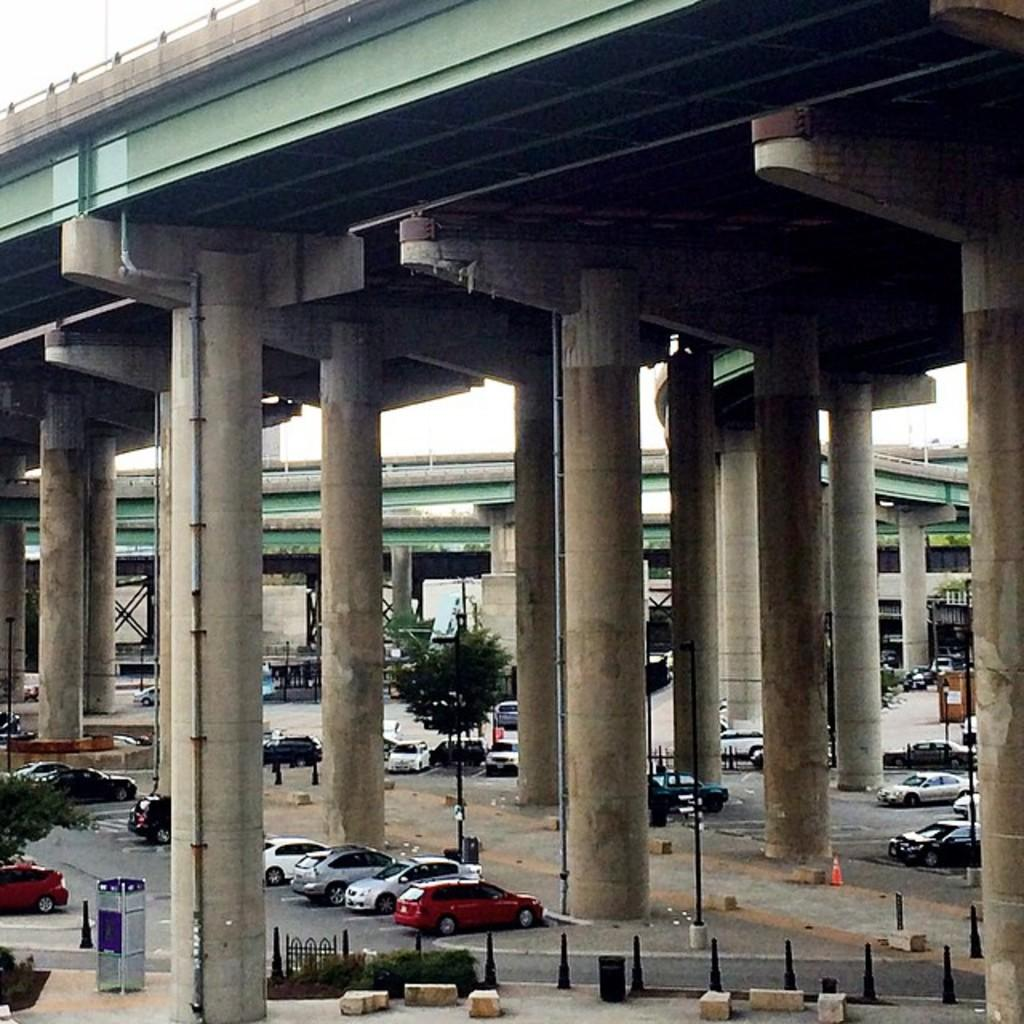What type of structure can be seen in the image? There are flyovers in the image. What is the color of the flyovers? The flyovers are green in color. What else can be seen in the image besides the flyovers? There is a road visible in the image. What is happening on the road in the image? Cars are parked on the road. What is the taste of the flyovers in the image? Flyovers are structures and do not have a taste. 